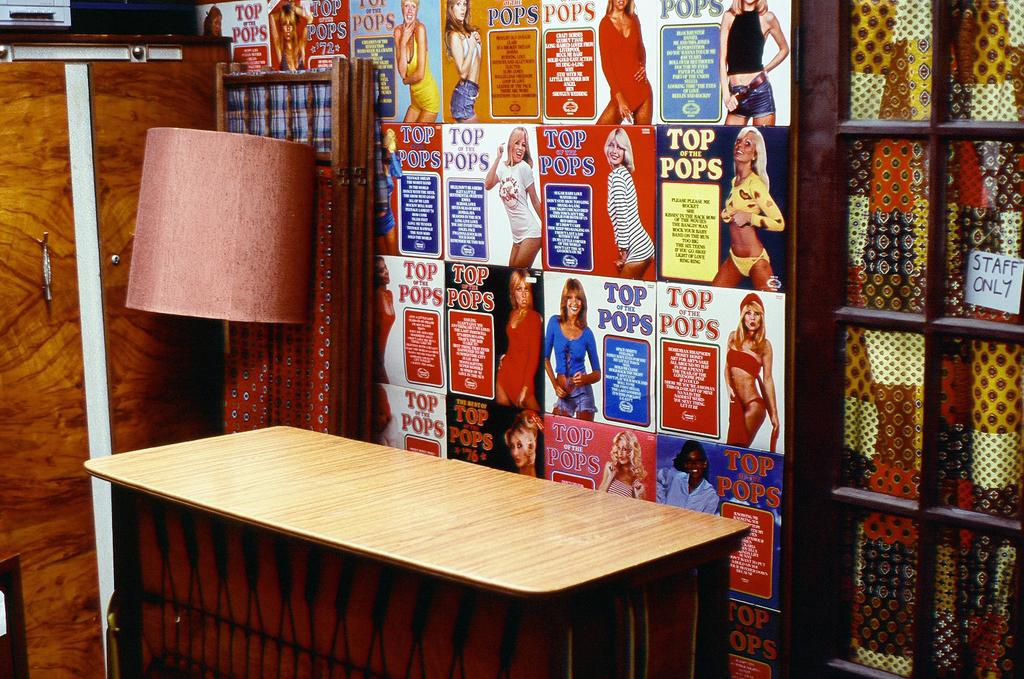<image>
Provide a brief description of the given image. Several advertisements for top of the pops iare lined up on a wall. 